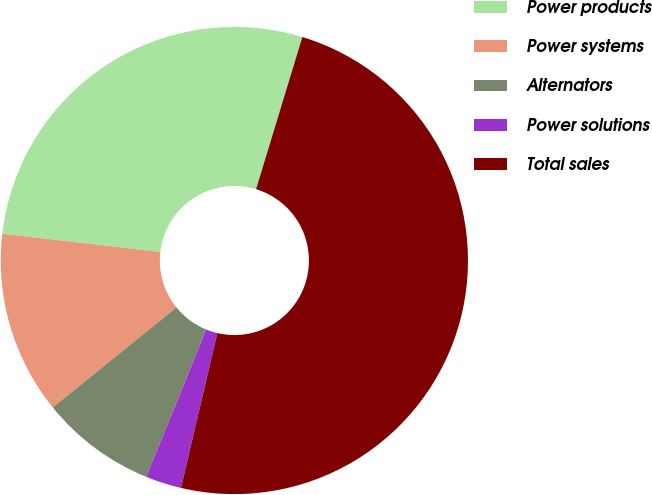Convert chart to OTSL. <chart><loc_0><loc_0><loc_500><loc_500><pie_chart><fcel>Power products<fcel>Power systems<fcel>Alternators<fcel>Power solutions<fcel>Total sales<nl><fcel>27.87%<fcel>12.66%<fcel>8.01%<fcel>2.49%<fcel>48.97%<nl></chart> 